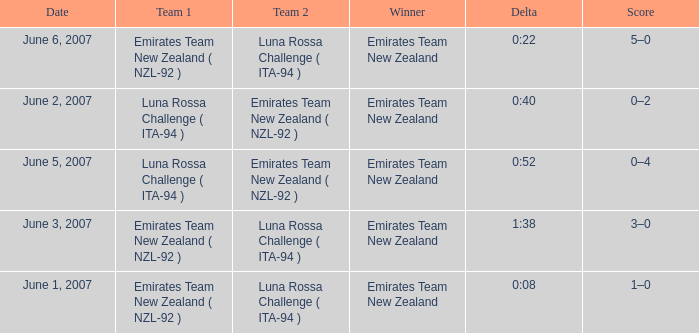Who is the Winner on June 2, 2007? Emirates Team New Zealand. 